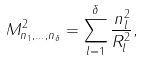<formula> <loc_0><loc_0><loc_500><loc_500>M _ { n _ { 1 } , \dots , n _ { \delta } } ^ { 2 } = \sum _ { l = 1 } ^ { \delta } \frac { n _ { l } ^ { 2 } } { R _ { l } ^ { 2 } } ,</formula> 